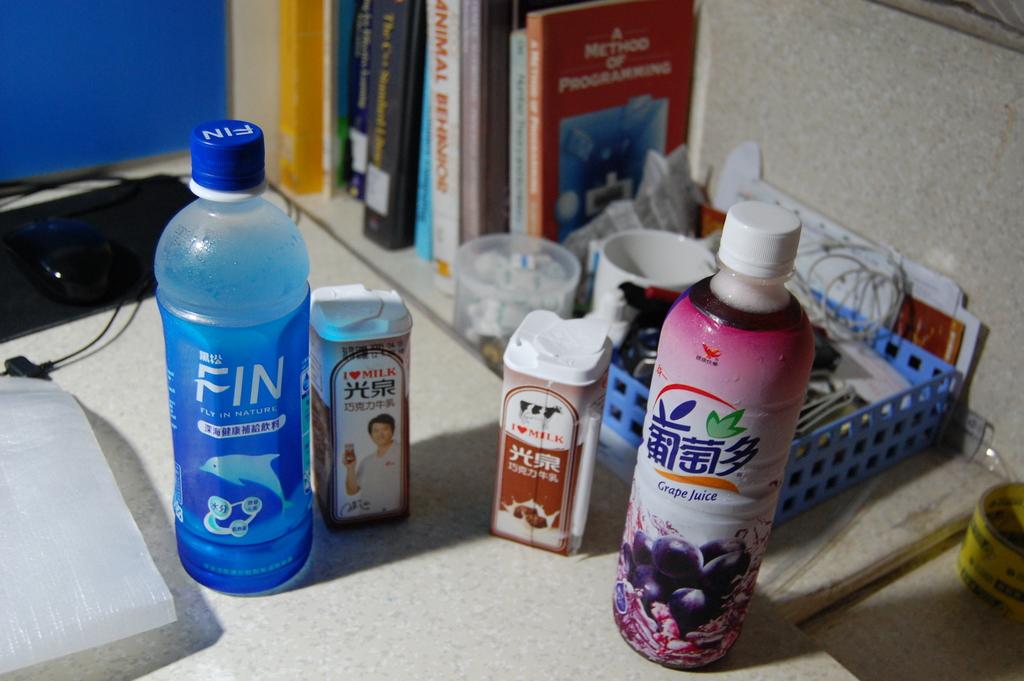What is writtten on the blue bottle in white?
Your answer should be very brief. Fin. 